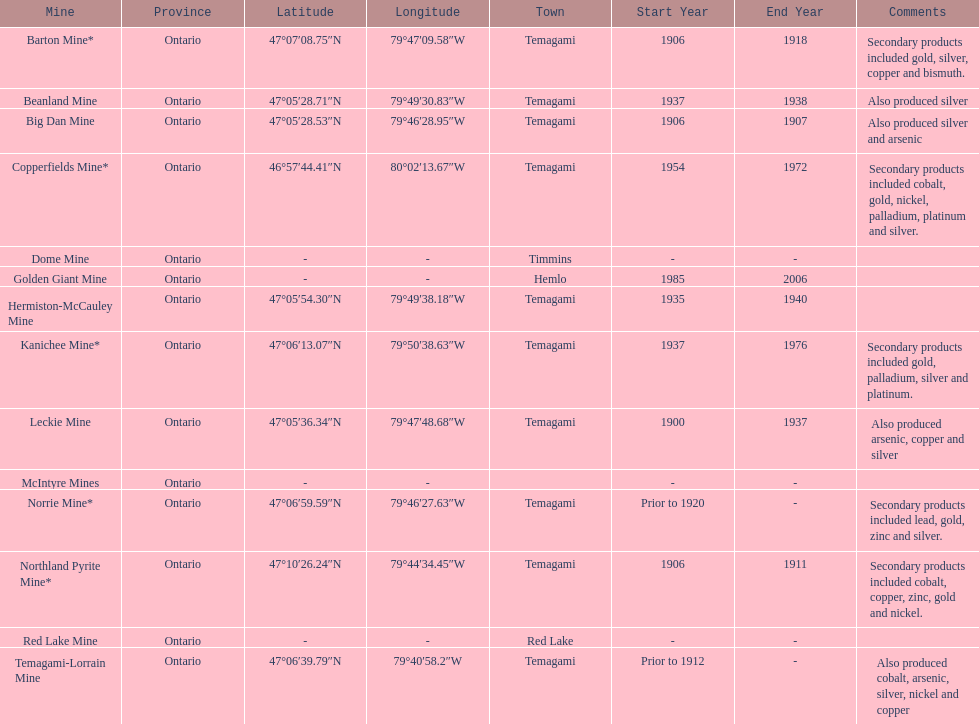How many mines were in temagami? 10. 